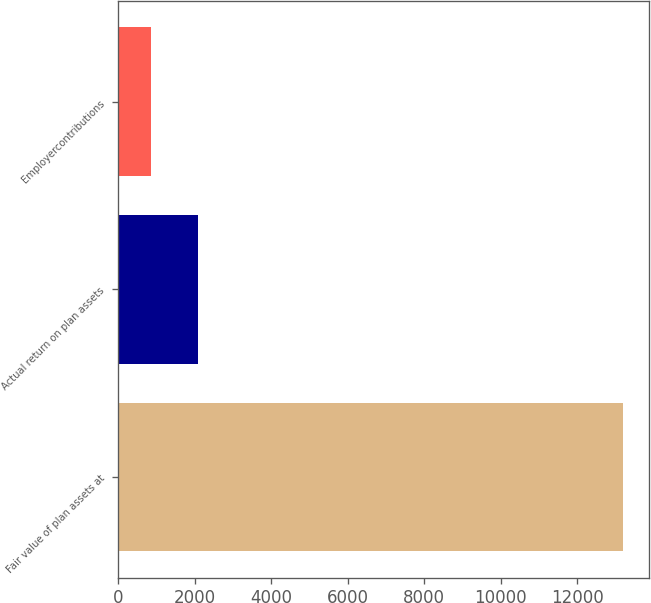Convert chart. <chart><loc_0><loc_0><loc_500><loc_500><bar_chart><fcel>Fair value of plan assets at<fcel>Actual return on plan assets<fcel>Employercontributions<nl><fcel>13209<fcel>2098.5<fcel>864<nl></chart> 